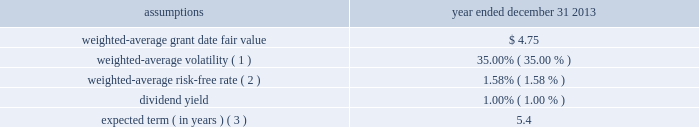Cdw corporation and subsidiaries notes to consolidated financial statements holders of class b common units in connection with the distribution is subject to any vesting provisions previously applicable to the holder 2019s class b common units .
Class b common unit holders received 3798508 shares of restricted stock with respect to class b common units that had not yet vested at the time of the distribution .
For the year ended december 31 , 2013 , 1200544 shares of such restricted stock vested/settled and 5931 shares were forfeited .
As of december 31 , 2013 , 2592033 shares of restricted stock were outstanding .
Stock options in addition , in connection with the ipo , the company issued 1268986 stock options to the class b common unit holders to preserve their fully diluted equity ownership percentage .
These options were issued with a per-share exercise price equal to the ipo price of $ 17.00 and are also subject to the same vesting provisions as the class b common units to which they relate .
The company also granted 19412 stock options under the 2013 ltip during the year ended december 31 , 2013 .
Restricted stock units ( 201crsus 201d ) in connection with the ipo , the company granted 1416543 rsus under the 2013 ltip at a weighted- average grant-date fair value of $ 17.03 per unit .
The rsus cliff-vest at the end of four years .
Valuation information the company attributes the value of equity-based compensation awards to the various periods during which the recipient must perform services in order to vest in the award using the straight-line method .
Post-ipo equity awards the company has elected to use the black-scholes option pricing model to estimate the fair value of stock options granted .
The black-scholes option pricing model incorporates various assumptions including volatility , expected term , risk-free interest rates and dividend yields .
The assumptions used to value the stock options granted during the year ended december 31 , 2013 are presented below .
Year ended december 31 , assumptions 2013 .
Expected term ( in years ) ( 3 ) .
5.4 ( 1 ) based upon an assessment of the two-year , five-year and implied volatility for the company 2019s selected peer group , adjusted for the company 2019s leverage .
( 2 ) based on a composite u.s .
Treasury rate .
( 3 ) the expected term is calculated using the simplified method .
The simplified method defines the expected term as the average of the option 2019s contractual term and the option 2019s weighted-average vesting period .
The company utilizes this method as it has limited historical stock option data that is sufficient to derive a reasonable estimate of the expected stock option term. .
Was the weighted-average risk-free rate greater than the dividend yield? 
Computations: (1.58 > 1)
Answer: yes. 